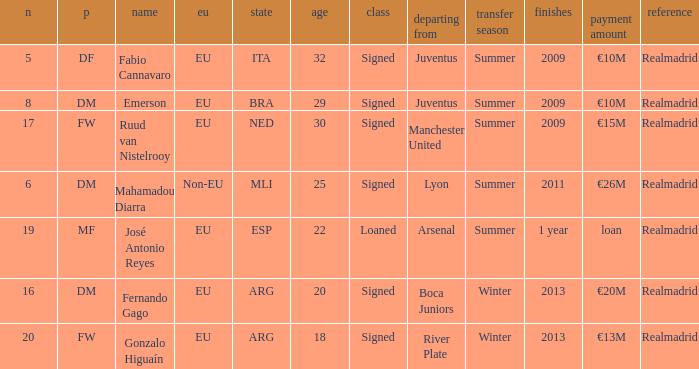How many numbers are ending in 1 year? 1.0. 